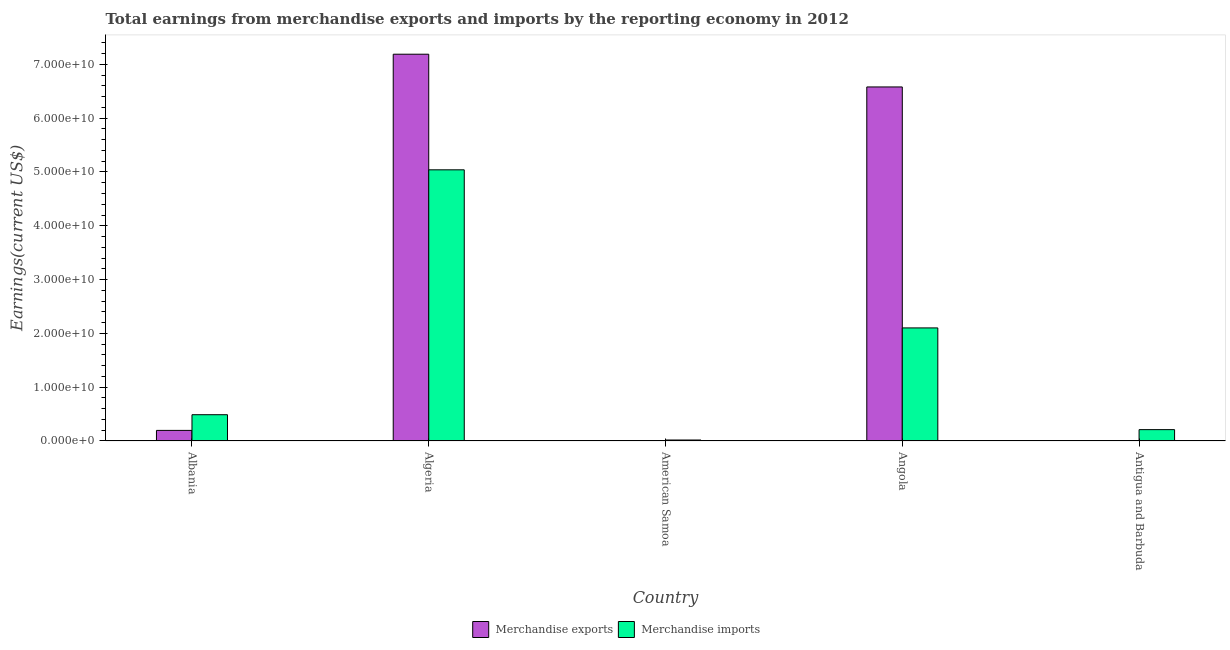How many different coloured bars are there?
Provide a succinct answer. 2. How many groups of bars are there?
Your answer should be very brief. 5. Are the number of bars on each tick of the X-axis equal?
Ensure brevity in your answer.  Yes. How many bars are there on the 5th tick from the left?
Offer a terse response. 2. What is the label of the 2nd group of bars from the left?
Your answer should be compact. Algeria. What is the earnings from merchandise exports in American Samoa?
Ensure brevity in your answer.  4.64e+07. Across all countries, what is the maximum earnings from merchandise exports?
Your answer should be very brief. 7.19e+1. Across all countries, what is the minimum earnings from merchandise exports?
Offer a very short reply. 4.64e+07. In which country was the earnings from merchandise imports maximum?
Make the answer very short. Algeria. In which country was the earnings from merchandise exports minimum?
Make the answer very short. American Samoa. What is the total earnings from merchandise imports in the graph?
Keep it short and to the point. 7.86e+1. What is the difference between the earnings from merchandise imports in Algeria and that in American Samoa?
Ensure brevity in your answer.  5.02e+1. What is the difference between the earnings from merchandise exports in Antigua and Barbuda and the earnings from merchandise imports in American Samoa?
Your answer should be compact. -1.07e+08. What is the average earnings from merchandise imports per country?
Keep it short and to the point. 1.57e+1. What is the difference between the earnings from merchandise exports and earnings from merchandise imports in Algeria?
Keep it short and to the point. 2.15e+1. What is the ratio of the earnings from merchandise imports in Albania to that in Antigua and Barbuda?
Give a very brief answer. 2.31. Is the difference between the earnings from merchandise exports in American Samoa and Antigua and Barbuda greater than the difference between the earnings from merchandise imports in American Samoa and Antigua and Barbuda?
Provide a short and direct response. Yes. What is the difference between the highest and the second highest earnings from merchandise imports?
Make the answer very short. 2.94e+1. What is the difference between the highest and the lowest earnings from merchandise exports?
Give a very brief answer. 7.18e+1. In how many countries, is the earnings from merchandise imports greater than the average earnings from merchandise imports taken over all countries?
Provide a short and direct response. 2. Is the sum of the earnings from merchandise exports in American Samoa and Antigua and Barbuda greater than the maximum earnings from merchandise imports across all countries?
Make the answer very short. No. How many countries are there in the graph?
Offer a very short reply. 5. What is the difference between two consecutive major ticks on the Y-axis?
Provide a short and direct response. 1.00e+1. How are the legend labels stacked?
Offer a very short reply. Horizontal. What is the title of the graph?
Ensure brevity in your answer.  Total earnings from merchandise exports and imports by the reporting economy in 2012. Does "Gasoline" appear as one of the legend labels in the graph?
Offer a very short reply. No. What is the label or title of the X-axis?
Ensure brevity in your answer.  Country. What is the label or title of the Y-axis?
Make the answer very short. Earnings(current US$). What is the Earnings(current US$) of Merchandise exports in Albania?
Make the answer very short. 1.97e+09. What is the Earnings(current US$) of Merchandise imports in Albania?
Your answer should be very brief. 4.88e+09. What is the Earnings(current US$) in Merchandise exports in Algeria?
Keep it short and to the point. 7.19e+1. What is the Earnings(current US$) in Merchandise imports in Algeria?
Offer a terse response. 5.04e+1. What is the Earnings(current US$) of Merchandise exports in American Samoa?
Ensure brevity in your answer.  4.64e+07. What is the Earnings(current US$) of Merchandise imports in American Samoa?
Offer a terse response. 1.83e+08. What is the Earnings(current US$) in Merchandise exports in Angola?
Offer a very short reply. 6.58e+1. What is the Earnings(current US$) of Merchandise imports in Angola?
Offer a very short reply. 2.10e+1. What is the Earnings(current US$) of Merchandise exports in Antigua and Barbuda?
Give a very brief answer. 7.62e+07. What is the Earnings(current US$) in Merchandise imports in Antigua and Barbuda?
Offer a terse response. 2.11e+09. Across all countries, what is the maximum Earnings(current US$) of Merchandise exports?
Provide a succinct answer. 7.19e+1. Across all countries, what is the maximum Earnings(current US$) of Merchandise imports?
Your answer should be compact. 5.04e+1. Across all countries, what is the minimum Earnings(current US$) in Merchandise exports?
Your answer should be compact. 4.64e+07. Across all countries, what is the minimum Earnings(current US$) of Merchandise imports?
Make the answer very short. 1.83e+08. What is the total Earnings(current US$) in Merchandise exports in the graph?
Keep it short and to the point. 1.40e+11. What is the total Earnings(current US$) of Merchandise imports in the graph?
Provide a succinct answer. 7.86e+1. What is the difference between the Earnings(current US$) in Merchandise exports in Albania and that in Algeria?
Provide a short and direct response. -6.99e+1. What is the difference between the Earnings(current US$) in Merchandise imports in Albania and that in Algeria?
Your response must be concise. -4.55e+1. What is the difference between the Earnings(current US$) in Merchandise exports in Albania and that in American Samoa?
Keep it short and to the point. 1.92e+09. What is the difference between the Earnings(current US$) in Merchandise imports in Albania and that in American Samoa?
Provide a short and direct response. 4.70e+09. What is the difference between the Earnings(current US$) of Merchandise exports in Albania and that in Angola?
Offer a very short reply. -6.38e+1. What is the difference between the Earnings(current US$) of Merchandise imports in Albania and that in Angola?
Your answer should be very brief. -1.61e+1. What is the difference between the Earnings(current US$) in Merchandise exports in Albania and that in Antigua and Barbuda?
Make the answer very short. 1.89e+09. What is the difference between the Earnings(current US$) in Merchandise imports in Albania and that in Antigua and Barbuda?
Your response must be concise. 2.77e+09. What is the difference between the Earnings(current US$) of Merchandise exports in Algeria and that in American Samoa?
Your response must be concise. 7.18e+1. What is the difference between the Earnings(current US$) of Merchandise imports in Algeria and that in American Samoa?
Make the answer very short. 5.02e+1. What is the difference between the Earnings(current US$) in Merchandise exports in Algeria and that in Angola?
Offer a very short reply. 6.08e+09. What is the difference between the Earnings(current US$) in Merchandise imports in Algeria and that in Angola?
Offer a terse response. 2.94e+1. What is the difference between the Earnings(current US$) of Merchandise exports in Algeria and that in Antigua and Barbuda?
Offer a very short reply. 7.18e+1. What is the difference between the Earnings(current US$) in Merchandise imports in Algeria and that in Antigua and Barbuda?
Ensure brevity in your answer.  4.83e+1. What is the difference between the Earnings(current US$) of Merchandise exports in American Samoa and that in Angola?
Offer a very short reply. -6.58e+1. What is the difference between the Earnings(current US$) in Merchandise imports in American Samoa and that in Angola?
Provide a succinct answer. -2.08e+1. What is the difference between the Earnings(current US$) of Merchandise exports in American Samoa and that in Antigua and Barbuda?
Keep it short and to the point. -2.98e+07. What is the difference between the Earnings(current US$) in Merchandise imports in American Samoa and that in Antigua and Barbuda?
Make the answer very short. -1.93e+09. What is the difference between the Earnings(current US$) of Merchandise exports in Angola and that in Antigua and Barbuda?
Your answer should be compact. 6.57e+1. What is the difference between the Earnings(current US$) in Merchandise imports in Angola and that in Antigua and Barbuda?
Keep it short and to the point. 1.89e+1. What is the difference between the Earnings(current US$) in Merchandise exports in Albania and the Earnings(current US$) in Merchandise imports in Algeria?
Make the answer very short. -4.84e+1. What is the difference between the Earnings(current US$) of Merchandise exports in Albania and the Earnings(current US$) of Merchandise imports in American Samoa?
Give a very brief answer. 1.79e+09. What is the difference between the Earnings(current US$) in Merchandise exports in Albania and the Earnings(current US$) in Merchandise imports in Angola?
Give a very brief answer. -1.90e+1. What is the difference between the Earnings(current US$) of Merchandise exports in Albania and the Earnings(current US$) of Merchandise imports in Antigua and Barbuda?
Offer a very short reply. -1.44e+08. What is the difference between the Earnings(current US$) in Merchandise exports in Algeria and the Earnings(current US$) in Merchandise imports in American Samoa?
Keep it short and to the point. 7.17e+1. What is the difference between the Earnings(current US$) of Merchandise exports in Algeria and the Earnings(current US$) of Merchandise imports in Angola?
Your answer should be compact. 5.09e+1. What is the difference between the Earnings(current US$) of Merchandise exports in Algeria and the Earnings(current US$) of Merchandise imports in Antigua and Barbuda?
Make the answer very short. 6.98e+1. What is the difference between the Earnings(current US$) in Merchandise exports in American Samoa and the Earnings(current US$) in Merchandise imports in Angola?
Give a very brief answer. -2.10e+1. What is the difference between the Earnings(current US$) of Merchandise exports in American Samoa and the Earnings(current US$) of Merchandise imports in Antigua and Barbuda?
Keep it short and to the point. -2.07e+09. What is the difference between the Earnings(current US$) of Merchandise exports in Angola and the Earnings(current US$) of Merchandise imports in Antigua and Barbuda?
Give a very brief answer. 6.37e+1. What is the average Earnings(current US$) of Merchandise exports per country?
Provide a succinct answer. 2.80e+1. What is the average Earnings(current US$) of Merchandise imports per country?
Offer a very short reply. 1.57e+1. What is the difference between the Earnings(current US$) in Merchandise exports and Earnings(current US$) in Merchandise imports in Albania?
Offer a very short reply. -2.92e+09. What is the difference between the Earnings(current US$) of Merchandise exports and Earnings(current US$) of Merchandise imports in Algeria?
Provide a succinct answer. 2.15e+1. What is the difference between the Earnings(current US$) in Merchandise exports and Earnings(current US$) in Merchandise imports in American Samoa?
Provide a succinct answer. -1.37e+08. What is the difference between the Earnings(current US$) in Merchandise exports and Earnings(current US$) in Merchandise imports in Angola?
Provide a succinct answer. 4.48e+1. What is the difference between the Earnings(current US$) of Merchandise exports and Earnings(current US$) of Merchandise imports in Antigua and Barbuda?
Offer a terse response. -2.04e+09. What is the ratio of the Earnings(current US$) in Merchandise exports in Albania to that in Algeria?
Offer a very short reply. 0.03. What is the ratio of the Earnings(current US$) of Merchandise imports in Albania to that in Algeria?
Your answer should be compact. 0.1. What is the ratio of the Earnings(current US$) in Merchandise exports in Albania to that in American Samoa?
Your answer should be very brief. 42.4. What is the ratio of the Earnings(current US$) of Merchandise imports in Albania to that in American Samoa?
Your response must be concise. 26.65. What is the ratio of the Earnings(current US$) in Merchandise exports in Albania to that in Angola?
Offer a terse response. 0.03. What is the ratio of the Earnings(current US$) of Merchandise imports in Albania to that in Angola?
Ensure brevity in your answer.  0.23. What is the ratio of the Earnings(current US$) of Merchandise exports in Albania to that in Antigua and Barbuda?
Your answer should be compact. 25.82. What is the ratio of the Earnings(current US$) of Merchandise imports in Albania to that in Antigua and Barbuda?
Offer a very short reply. 2.31. What is the ratio of the Earnings(current US$) of Merchandise exports in Algeria to that in American Samoa?
Make the answer very short. 1548.05. What is the ratio of the Earnings(current US$) in Merchandise imports in Algeria to that in American Samoa?
Offer a terse response. 275. What is the ratio of the Earnings(current US$) of Merchandise exports in Algeria to that in Angola?
Your answer should be very brief. 1.09. What is the ratio of the Earnings(current US$) of Merchandise imports in Algeria to that in Angola?
Provide a succinct answer. 2.4. What is the ratio of the Earnings(current US$) in Merchandise exports in Algeria to that in Antigua and Barbuda?
Ensure brevity in your answer.  942.88. What is the ratio of the Earnings(current US$) in Merchandise imports in Algeria to that in Antigua and Barbuda?
Make the answer very short. 23.86. What is the ratio of the Earnings(current US$) of Merchandise exports in American Samoa to that in Angola?
Provide a succinct answer. 0. What is the ratio of the Earnings(current US$) in Merchandise imports in American Samoa to that in Angola?
Your answer should be very brief. 0.01. What is the ratio of the Earnings(current US$) in Merchandise exports in American Samoa to that in Antigua and Barbuda?
Provide a succinct answer. 0.61. What is the ratio of the Earnings(current US$) in Merchandise imports in American Samoa to that in Antigua and Barbuda?
Provide a short and direct response. 0.09. What is the ratio of the Earnings(current US$) in Merchandise exports in Angola to that in Antigua and Barbuda?
Ensure brevity in your answer.  863.09. What is the ratio of the Earnings(current US$) of Merchandise imports in Angola to that in Antigua and Barbuda?
Offer a very short reply. 9.95. What is the difference between the highest and the second highest Earnings(current US$) of Merchandise exports?
Give a very brief answer. 6.08e+09. What is the difference between the highest and the second highest Earnings(current US$) of Merchandise imports?
Offer a very short reply. 2.94e+1. What is the difference between the highest and the lowest Earnings(current US$) of Merchandise exports?
Your response must be concise. 7.18e+1. What is the difference between the highest and the lowest Earnings(current US$) in Merchandise imports?
Ensure brevity in your answer.  5.02e+1. 